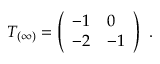Convert formula to latex. <formula><loc_0><loc_0><loc_500><loc_500>T _ { ( \infty ) } = \left ( \begin{array} { l l } { - 1 } & { 0 } \\ { - 2 } & { - 1 } \end{array} \right ) \ .</formula> 